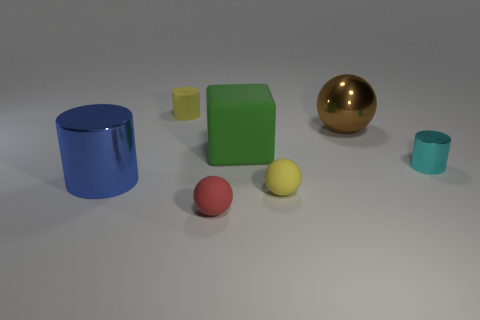How big is the metal thing that is in front of the cylinder on the right side of the tiny yellow cylinder?
Ensure brevity in your answer.  Large. There is a small thing that is both behind the yellow ball and to the left of the big green object; what material is it made of?
Keep it short and to the point. Rubber. What color is the big shiny cylinder?
Make the answer very short. Blue. There is a yellow thing that is behind the small metal thing; what shape is it?
Offer a terse response. Cylinder. There is a metal cylinder that is right of the big metallic thing that is to the left of the tiny matte cylinder; are there any small yellow things that are behind it?
Offer a terse response. Yes. Is there any other thing that is the same shape as the tiny cyan thing?
Make the answer very short. Yes. Are any big balls visible?
Make the answer very short. Yes. Are the tiny thing that is right of the yellow matte sphere and the cylinder behind the shiny ball made of the same material?
Give a very brief answer. No. How big is the sphere that is to the left of the tiny yellow matte thing that is in front of the cylinder in front of the small cyan cylinder?
Give a very brief answer. Small. How many big objects are the same material as the large ball?
Offer a very short reply. 1. 